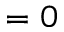<formula> <loc_0><loc_0><loc_500><loc_500>= 0</formula> 